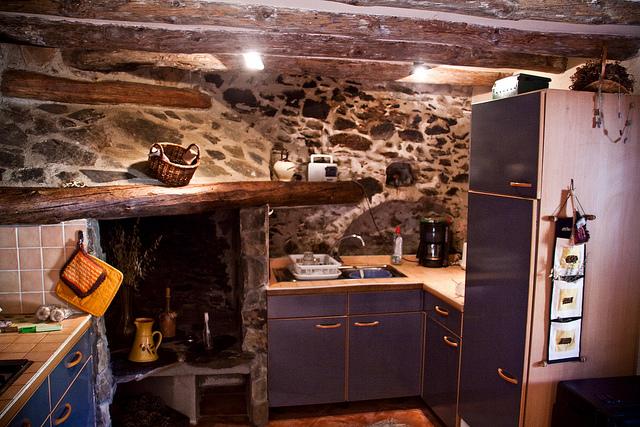Is the cupboard opened or closed?
Write a very short answer. Closed. What room is this?
Quick response, please. Kitchen. What are the walls made of?
Keep it brief. Stone. 